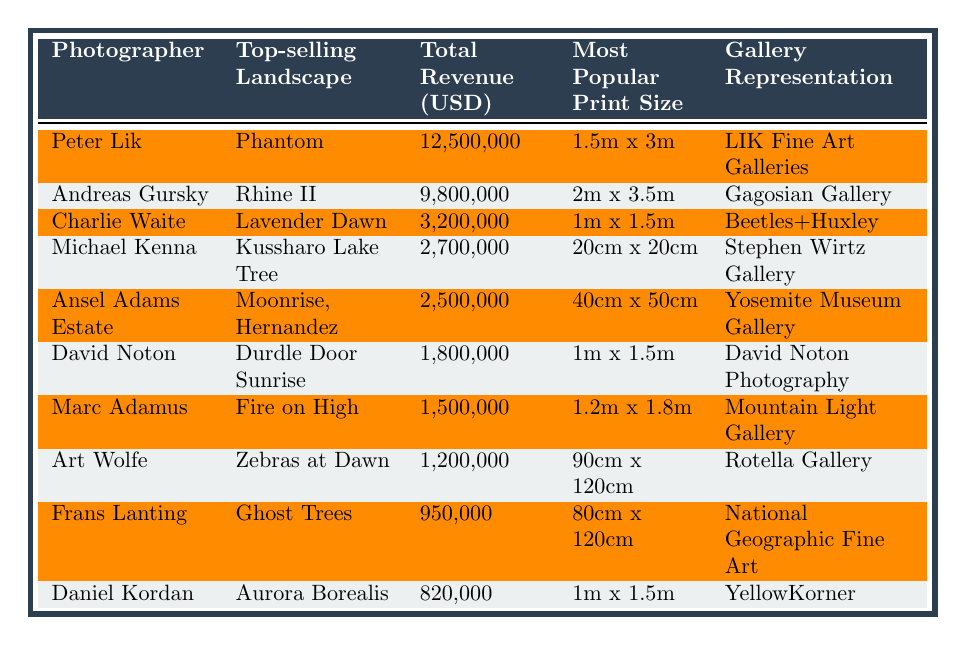What is the total revenue earned by Peter Lik in 2022? From the table, Peter Lik's total revenue is explicitly listed as 12,500,000 USD.
Answer: 12,500,000 USD Who represented Michael Kenna in 2022? The "Gallery Representation" column indicates that Michael Kenna was represented by Stephen Wirtz Gallery.
Answer: Stephen Wirtz Gallery Which photographer had the lowest revenue in 2022? By comparing the total revenues, Daniel Kordan at 820,000 USD has the lowest revenue listed in the table.
Answer: Daniel Kordan What is the most popular print size for David Noton? The "Most Popular Print Size" column shows that David Noton's preferred size is 1m x 1.5m.
Answer: 1m x 1.5m How much total revenue was generated by Ansel Adams Estate and Marc Adamus combined? Ansel Adams Estate's revenue is 2,500,000 USD, and Marc Adamus's revenue is 1,500,000 USD. Combining these gives 2,500,000 + 1,500,000 = 4,000,000 USD.
Answer: 4,000,000 USD Is it true that Art Wolfe's revenue is greater than that of Charlie Waite? Art Wolfe has a revenue of 1,200,000 USD, while Charlie Waite's revenue is 3,200,000 USD. Since 1,200,000 is less than 3,200,000, the statement is false.
Answer: No What is the average revenue of the top three photographers listed? The top three photographers are Peter Lik (12,500,000 USD), Andreas Gursky (9,800,000 USD), and Charlie Waite (3,200,000 USD). Their total revenue is 12,500,000 + 9,800,000 + 3,200,000 = 25,500,000 USD. Dividing by 3 gives an average of 25,500,000 / 3 = 8,500,000 USD.
Answer: 8,500,000 USD Which gallery represents the highest earning photographer? Peter Lik, the highest earning photographer with a revenue of 12,500,000 USD, is represented by LIK Fine Art Galleries.
Answer: LIK Fine Art Galleries Which photographer has a print size of 90cm x 120cm? From the table, Art Wolfe is listed with a most popular print size of 90cm x 120cm.
Answer: Art Wolfe What is the difference in revenue between the top-selling photographer and the lowest-selling photographer? The revenue for Peter Lik (top-selling) is 12,500,000 USD, and for Daniel Kordan (lowest-selling), it is 820,000 USD. The difference is 12,500,000 - 820,000 = 11,680,000 USD.
Answer: 11,680,000 USD 